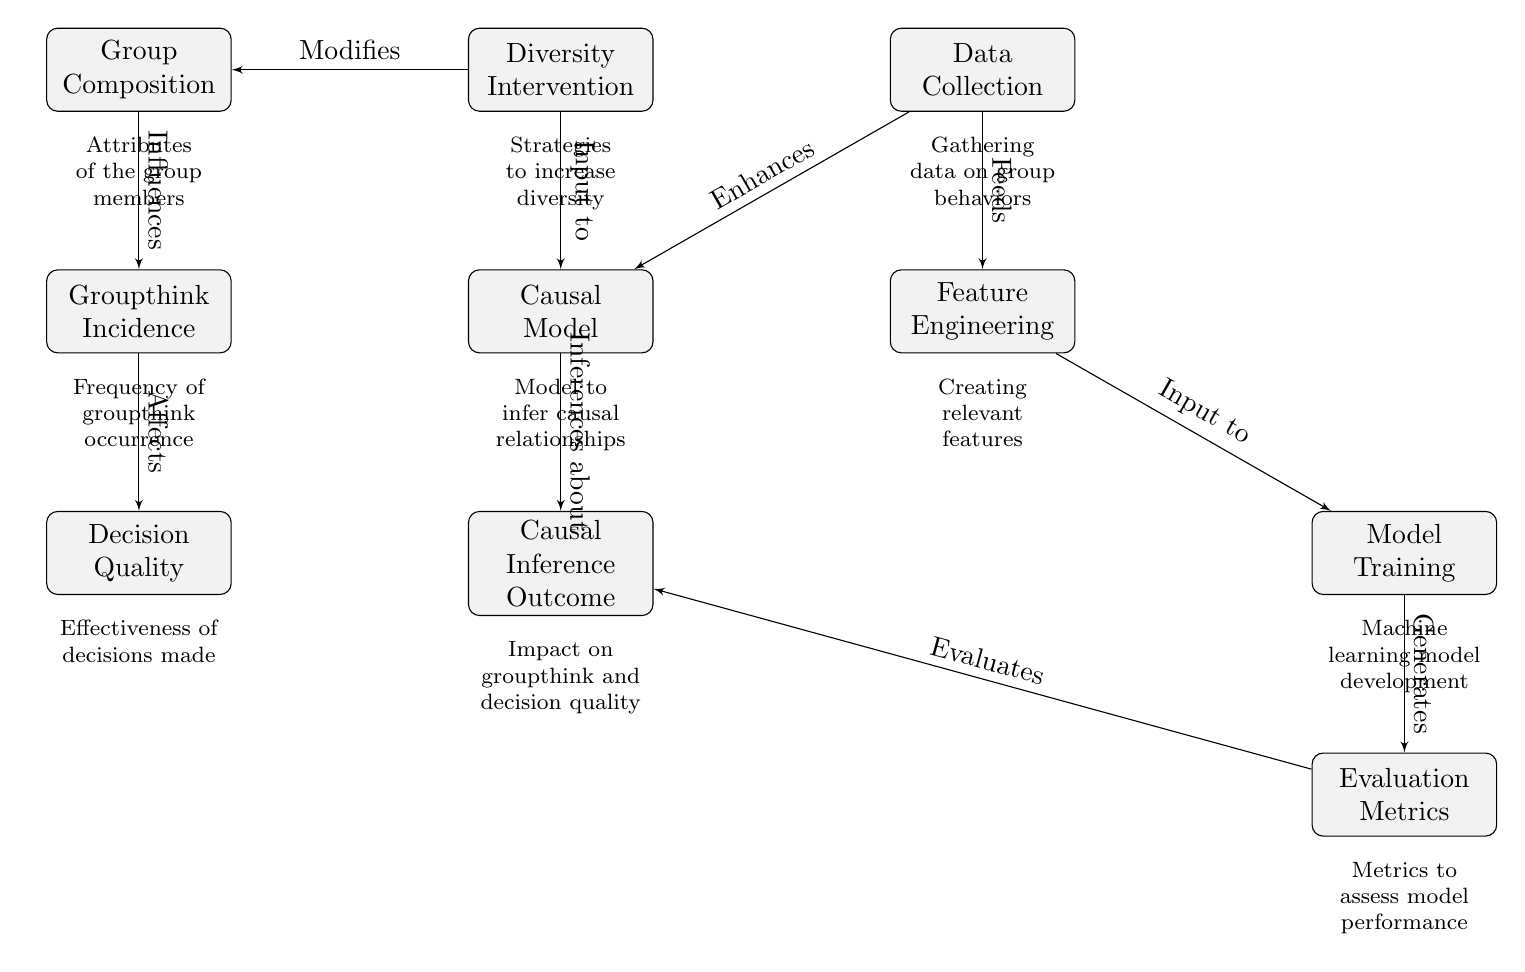What is the first node in the diagram? The first node in the diagram is labeled "Group Composition." This can be found at the top left corner of the diagram.
Answer: Group Composition Which node receives input from "Diversity Intervention"? The node receiving input from "Diversity Intervention" is "Causal Model." This relationship is established by the arrow pointing from "Diversity Intervention" to "Causal Model."
Answer: Causal Model How many nodes are present in the diagram? By counting the nodes represented, there are a total of ten nodes in the diagram. Each rectangle represents a specific concept or task related to the causal inference approach.
Answer: Ten What is the relationship between "Groupthink Incidence" and "Decision Quality"? The relationship is that "Groupthink Incidence" affects "Decision Quality," as indicated by the arrow from "Groupthink Incidence" pointing to "Decision Quality."
Answer: Affects Describe the flow of influence from "Data Collection" to "Causal Inference Outcome." "Data Collection" enhances the "Causal Model" and feeds into "Feature Engineering," which creates relevant features used in "Model Training." After training, the outputs are evaluated using "Evaluation Metrics," which ultimately provides inferences about "Causal Inference Outcome." Each step builds upon the previous one, leading to the final outcome.
Answer: Data Collection enhances Causal Model, feeds Feature Engineering, input to Model Training, generates Evaluation Metrics, leads to Causal Inference Outcome What does "Model Training" generate? "Model Training" generates "Evaluation Metrics." The arrow indicates that the output of the training process feeds into metrics to assess the performance of the model developed.
Answer: Evaluation Metrics What is the role of "Feature Engineering" in the diagram? "Feature Engineering" is a process that takes outputs from data collection to create relevant features needed for training the machine learning model, indicating its pivotal role in preparing data for analysis.
Answer: Creates relevant features Which node indicates the incidence of groupthink? The node indicating the incidence of groupthink is labeled "Groupthink Incidence." This node is positioned below "Group Composition" in the flow of the diagram.
Answer: Groupthink Incidence 